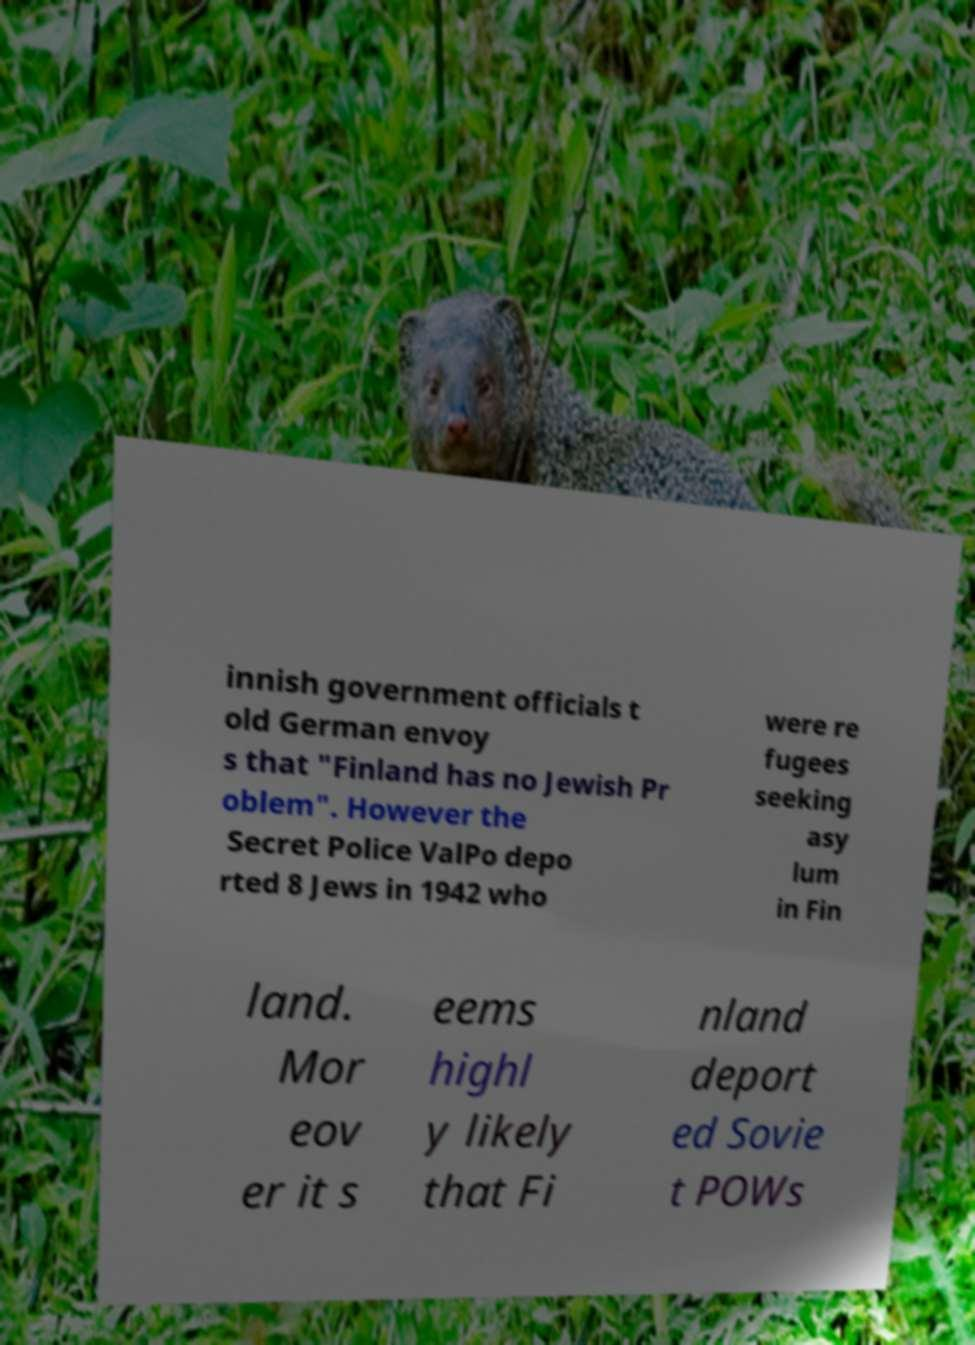For documentation purposes, I need the text within this image transcribed. Could you provide that? innish government officials t old German envoy s that "Finland has no Jewish Pr oblem". However the Secret Police ValPo depo rted 8 Jews in 1942 who were re fugees seeking asy lum in Fin land. Mor eov er it s eems highl y likely that Fi nland deport ed Sovie t POWs 